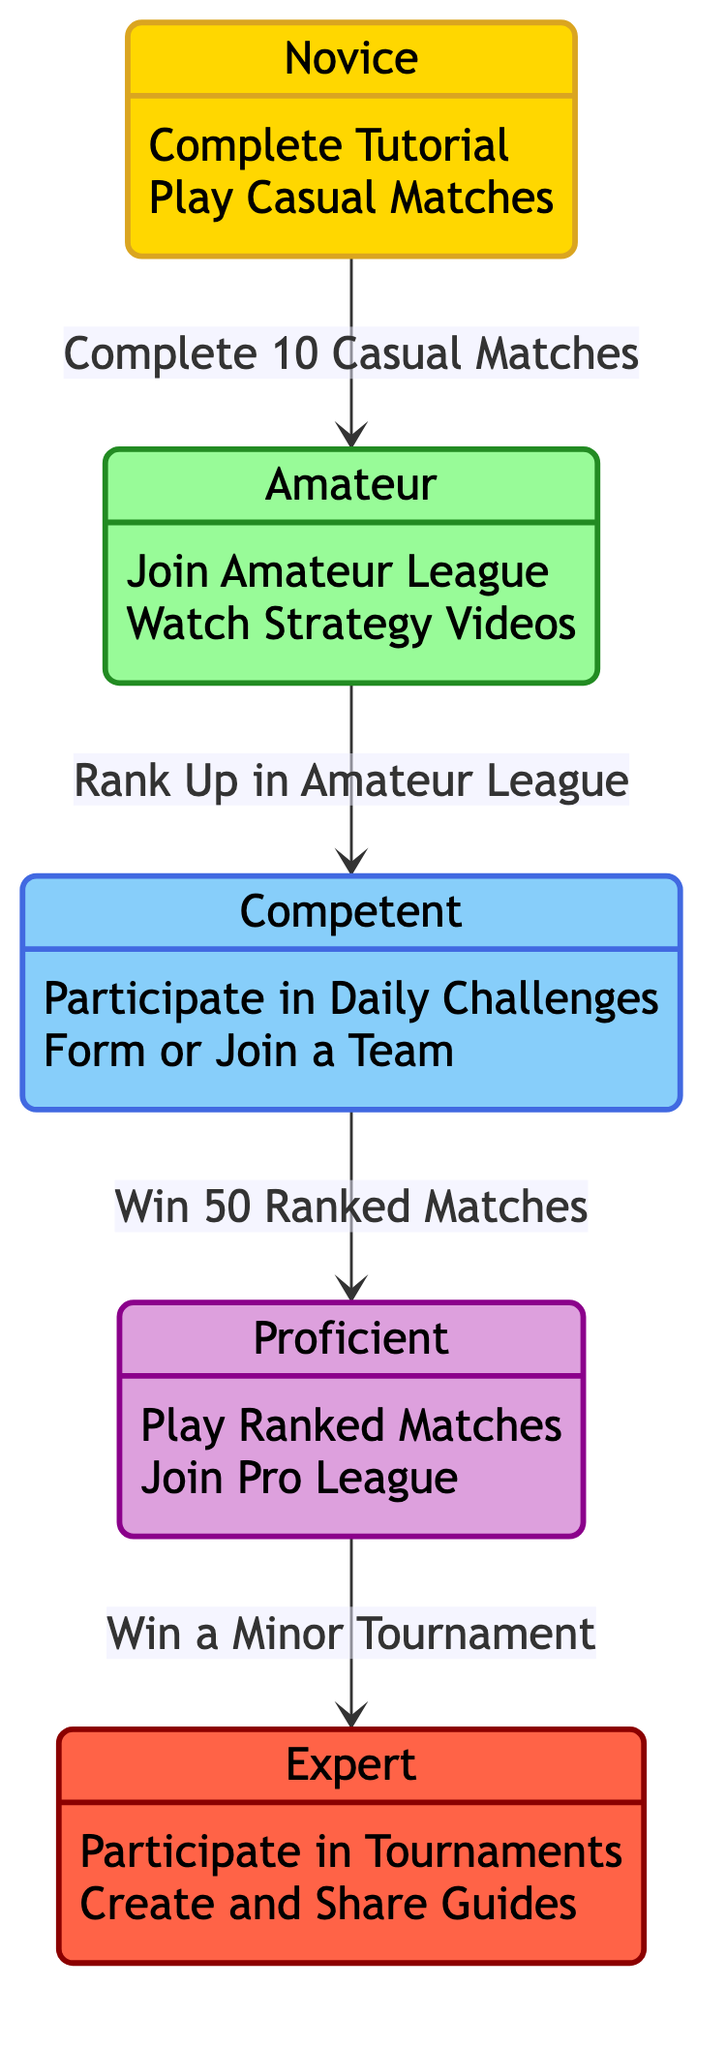What is the number of states in the diagram? The diagram includes five distinct states: Novice, Amateur, Competent, Proficient, and Expert. This can be confirmed by counting the labeled states within the diagram.
Answer: 5 What action is required to transition from Novice to Amateur? To transition from Novice to Amateur, the player must complete 10 Casual Matches. This action is indicated on the transition line connecting the Novice state to the Amateur state in the diagram.
Answer: Complete 10 Casual Matches What is the last state a player can reach in this progression? The last state a player can reach is Expert. This is the final state detailed in the diagram, indicating the highest level of player progression.
Answer: Expert Which state requires winning a Minor Tournament to progress? Winning a Minor Tournament is the condition for progressing from Proficient to Expert. The transition is depicted from the Proficient state to the Expert state, specifying this requirement.
Answer: Proficient What action can a player take while in the Competent state? A player in the Competent state can participate in Daily Challenges. This action is listed under the Competent state description in the diagram.
Answer: Participate in Daily Challenges What actions can players take while in the Novice state? Players in the Novice state can take two actions: complete the Tutorial and play Casual Matches. Both actions are clearly listed under the Novice state description in the diagram.
Answer: Complete Tutorial, Play Casual Matches What must a player achieve to transition from Amateur to Competent? To transition from Amateur to Competent, a player must rank up in the Amateur League. This requirement is indicated on the transition line from the Amateur state to the Competent state.
Answer: Rank Up in Amateur League What does the transition from Competent to Proficient require? The transition from Competent to Proficient requires the player to win 50 Ranked Matches. This condition is stated on the arrow connecting these two states.
Answer: Win 50 Ranked Matches 